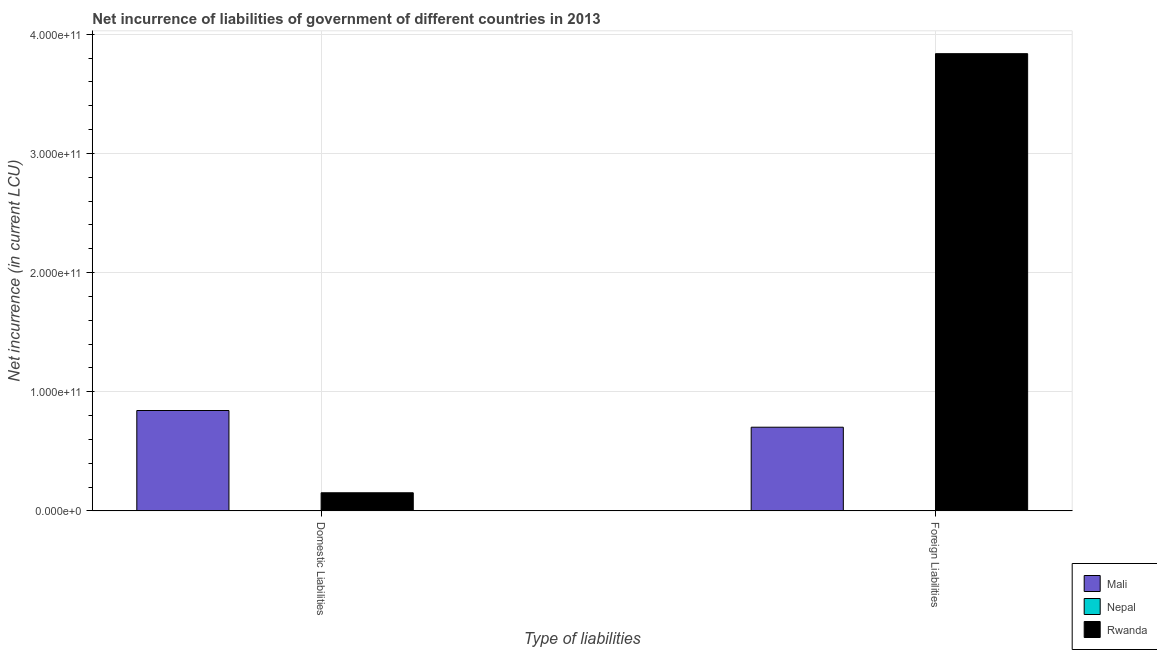How many different coloured bars are there?
Make the answer very short. 2. Are the number of bars per tick equal to the number of legend labels?
Your answer should be compact. No. How many bars are there on the 2nd tick from the right?
Keep it short and to the point. 2. What is the label of the 1st group of bars from the left?
Your answer should be very brief. Domestic Liabilities. Across all countries, what is the maximum net incurrence of foreign liabilities?
Your answer should be compact. 3.84e+11. Across all countries, what is the minimum net incurrence of foreign liabilities?
Keep it short and to the point. 0. In which country was the net incurrence of domestic liabilities maximum?
Ensure brevity in your answer.  Mali. What is the total net incurrence of foreign liabilities in the graph?
Provide a succinct answer. 4.54e+11. What is the difference between the net incurrence of foreign liabilities in Rwanda and that in Mali?
Make the answer very short. 3.13e+11. What is the difference between the net incurrence of foreign liabilities in Mali and the net incurrence of domestic liabilities in Nepal?
Your response must be concise. 7.02e+1. What is the average net incurrence of foreign liabilities per country?
Keep it short and to the point. 1.51e+11. What is the difference between the net incurrence of foreign liabilities and net incurrence of domestic liabilities in Rwanda?
Your response must be concise. 3.68e+11. In how many countries, is the net incurrence of domestic liabilities greater than 200000000000 LCU?
Offer a very short reply. 0. What is the ratio of the net incurrence of domestic liabilities in Mali to that in Rwanda?
Provide a short and direct response. 5.54. Is the net incurrence of domestic liabilities in Mali less than that in Rwanda?
Make the answer very short. No. In how many countries, is the net incurrence of domestic liabilities greater than the average net incurrence of domestic liabilities taken over all countries?
Your answer should be very brief. 1. Are all the bars in the graph horizontal?
Your answer should be very brief. No. How many countries are there in the graph?
Provide a short and direct response. 3. What is the difference between two consecutive major ticks on the Y-axis?
Your answer should be compact. 1.00e+11. Are the values on the major ticks of Y-axis written in scientific E-notation?
Give a very brief answer. Yes. Does the graph contain any zero values?
Offer a terse response. Yes. Where does the legend appear in the graph?
Provide a short and direct response. Bottom right. What is the title of the graph?
Your answer should be very brief. Net incurrence of liabilities of government of different countries in 2013. What is the label or title of the X-axis?
Give a very brief answer. Type of liabilities. What is the label or title of the Y-axis?
Offer a very short reply. Net incurrence (in current LCU). What is the Net incurrence (in current LCU) in Mali in Domestic Liabilities?
Provide a succinct answer. 8.42e+1. What is the Net incurrence (in current LCU) in Rwanda in Domestic Liabilities?
Keep it short and to the point. 1.52e+1. What is the Net incurrence (in current LCU) in Mali in Foreign Liabilities?
Provide a succinct answer. 7.02e+1. What is the Net incurrence (in current LCU) in Rwanda in Foreign Liabilities?
Ensure brevity in your answer.  3.84e+11. Across all Type of liabilities, what is the maximum Net incurrence (in current LCU) in Mali?
Provide a succinct answer. 8.42e+1. Across all Type of liabilities, what is the maximum Net incurrence (in current LCU) in Rwanda?
Give a very brief answer. 3.84e+11. Across all Type of liabilities, what is the minimum Net incurrence (in current LCU) of Mali?
Provide a short and direct response. 7.02e+1. Across all Type of liabilities, what is the minimum Net incurrence (in current LCU) in Rwanda?
Keep it short and to the point. 1.52e+1. What is the total Net incurrence (in current LCU) in Mali in the graph?
Provide a succinct answer. 1.54e+11. What is the total Net incurrence (in current LCU) of Rwanda in the graph?
Ensure brevity in your answer.  3.99e+11. What is the difference between the Net incurrence (in current LCU) of Mali in Domestic Liabilities and that in Foreign Liabilities?
Provide a succinct answer. 1.40e+1. What is the difference between the Net incurrence (in current LCU) in Rwanda in Domestic Liabilities and that in Foreign Liabilities?
Offer a very short reply. -3.68e+11. What is the difference between the Net incurrence (in current LCU) of Mali in Domestic Liabilities and the Net incurrence (in current LCU) of Rwanda in Foreign Liabilities?
Make the answer very short. -2.99e+11. What is the average Net incurrence (in current LCU) in Mali per Type of liabilities?
Make the answer very short. 7.72e+1. What is the average Net incurrence (in current LCU) in Nepal per Type of liabilities?
Provide a succinct answer. 0. What is the average Net incurrence (in current LCU) in Rwanda per Type of liabilities?
Keep it short and to the point. 1.99e+11. What is the difference between the Net incurrence (in current LCU) in Mali and Net incurrence (in current LCU) in Rwanda in Domestic Liabilities?
Provide a short and direct response. 6.90e+1. What is the difference between the Net incurrence (in current LCU) in Mali and Net incurrence (in current LCU) in Rwanda in Foreign Liabilities?
Provide a short and direct response. -3.13e+11. What is the ratio of the Net incurrence (in current LCU) of Mali in Domestic Liabilities to that in Foreign Liabilities?
Provide a succinct answer. 1.2. What is the ratio of the Net incurrence (in current LCU) of Rwanda in Domestic Liabilities to that in Foreign Liabilities?
Your answer should be very brief. 0.04. What is the difference between the highest and the second highest Net incurrence (in current LCU) of Mali?
Provide a succinct answer. 1.40e+1. What is the difference between the highest and the second highest Net incurrence (in current LCU) in Rwanda?
Your response must be concise. 3.68e+11. What is the difference between the highest and the lowest Net incurrence (in current LCU) of Mali?
Ensure brevity in your answer.  1.40e+1. What is the difference between the highest and the lowest Net incurrence (in current LCU) of Rwanda?
Ensure brevity in your answer.  3.68e+11. 